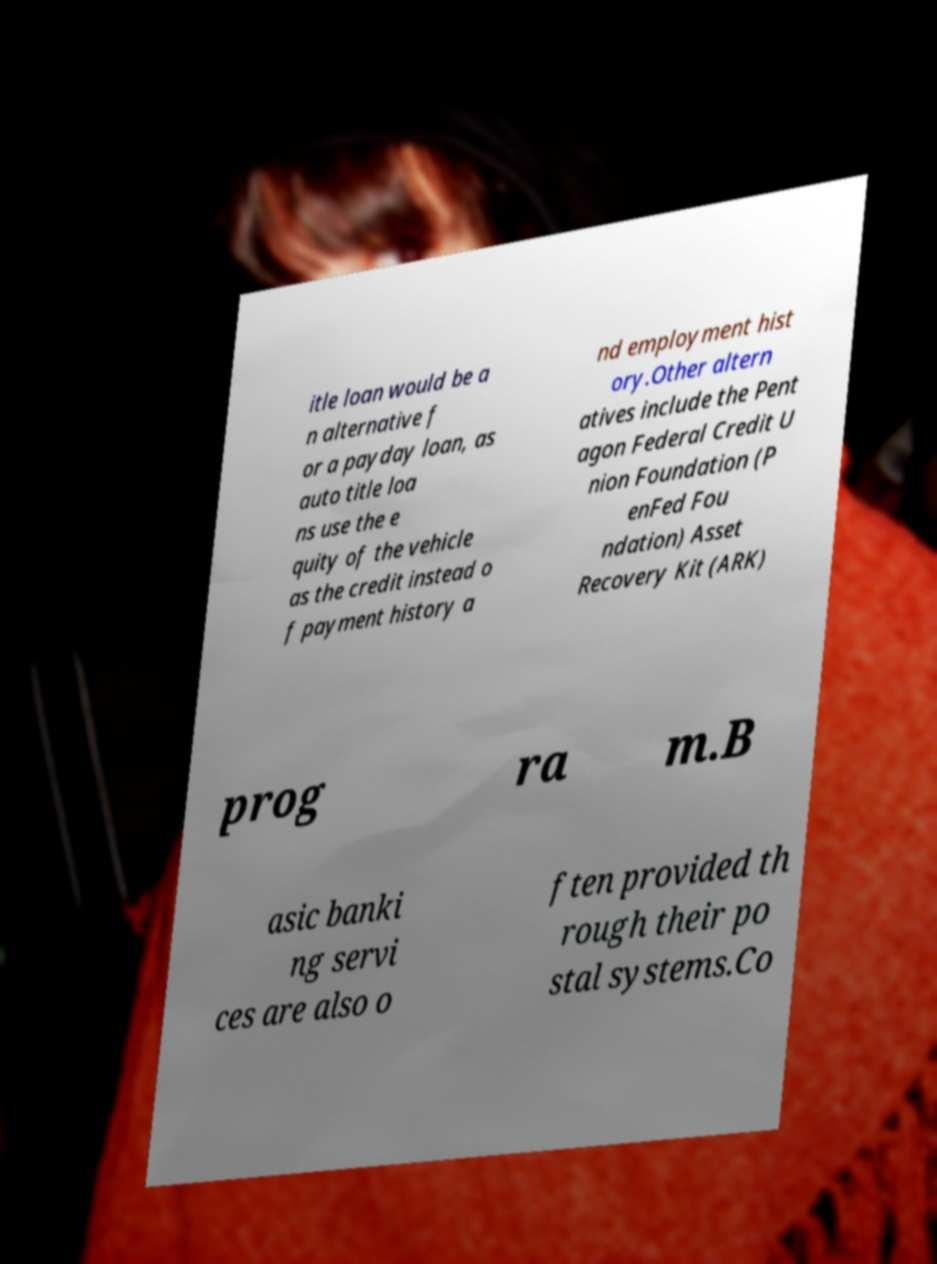Can you accurately transcribe the text from the provided image for me? itle loan would be a n alternative f or a payday loan, as auto title loa ns use the e quity of the vehicle as the credit instead o f payment history a nd employment hist ory.Other altern atives include the Pent agon Federal Credit U nion Foundation (P enFed Fou ndation) Asset Recovery Kit (ARK) prog ra m.B asic banki ng servi ces are also o ften provided th rough their po stal systems.Co 